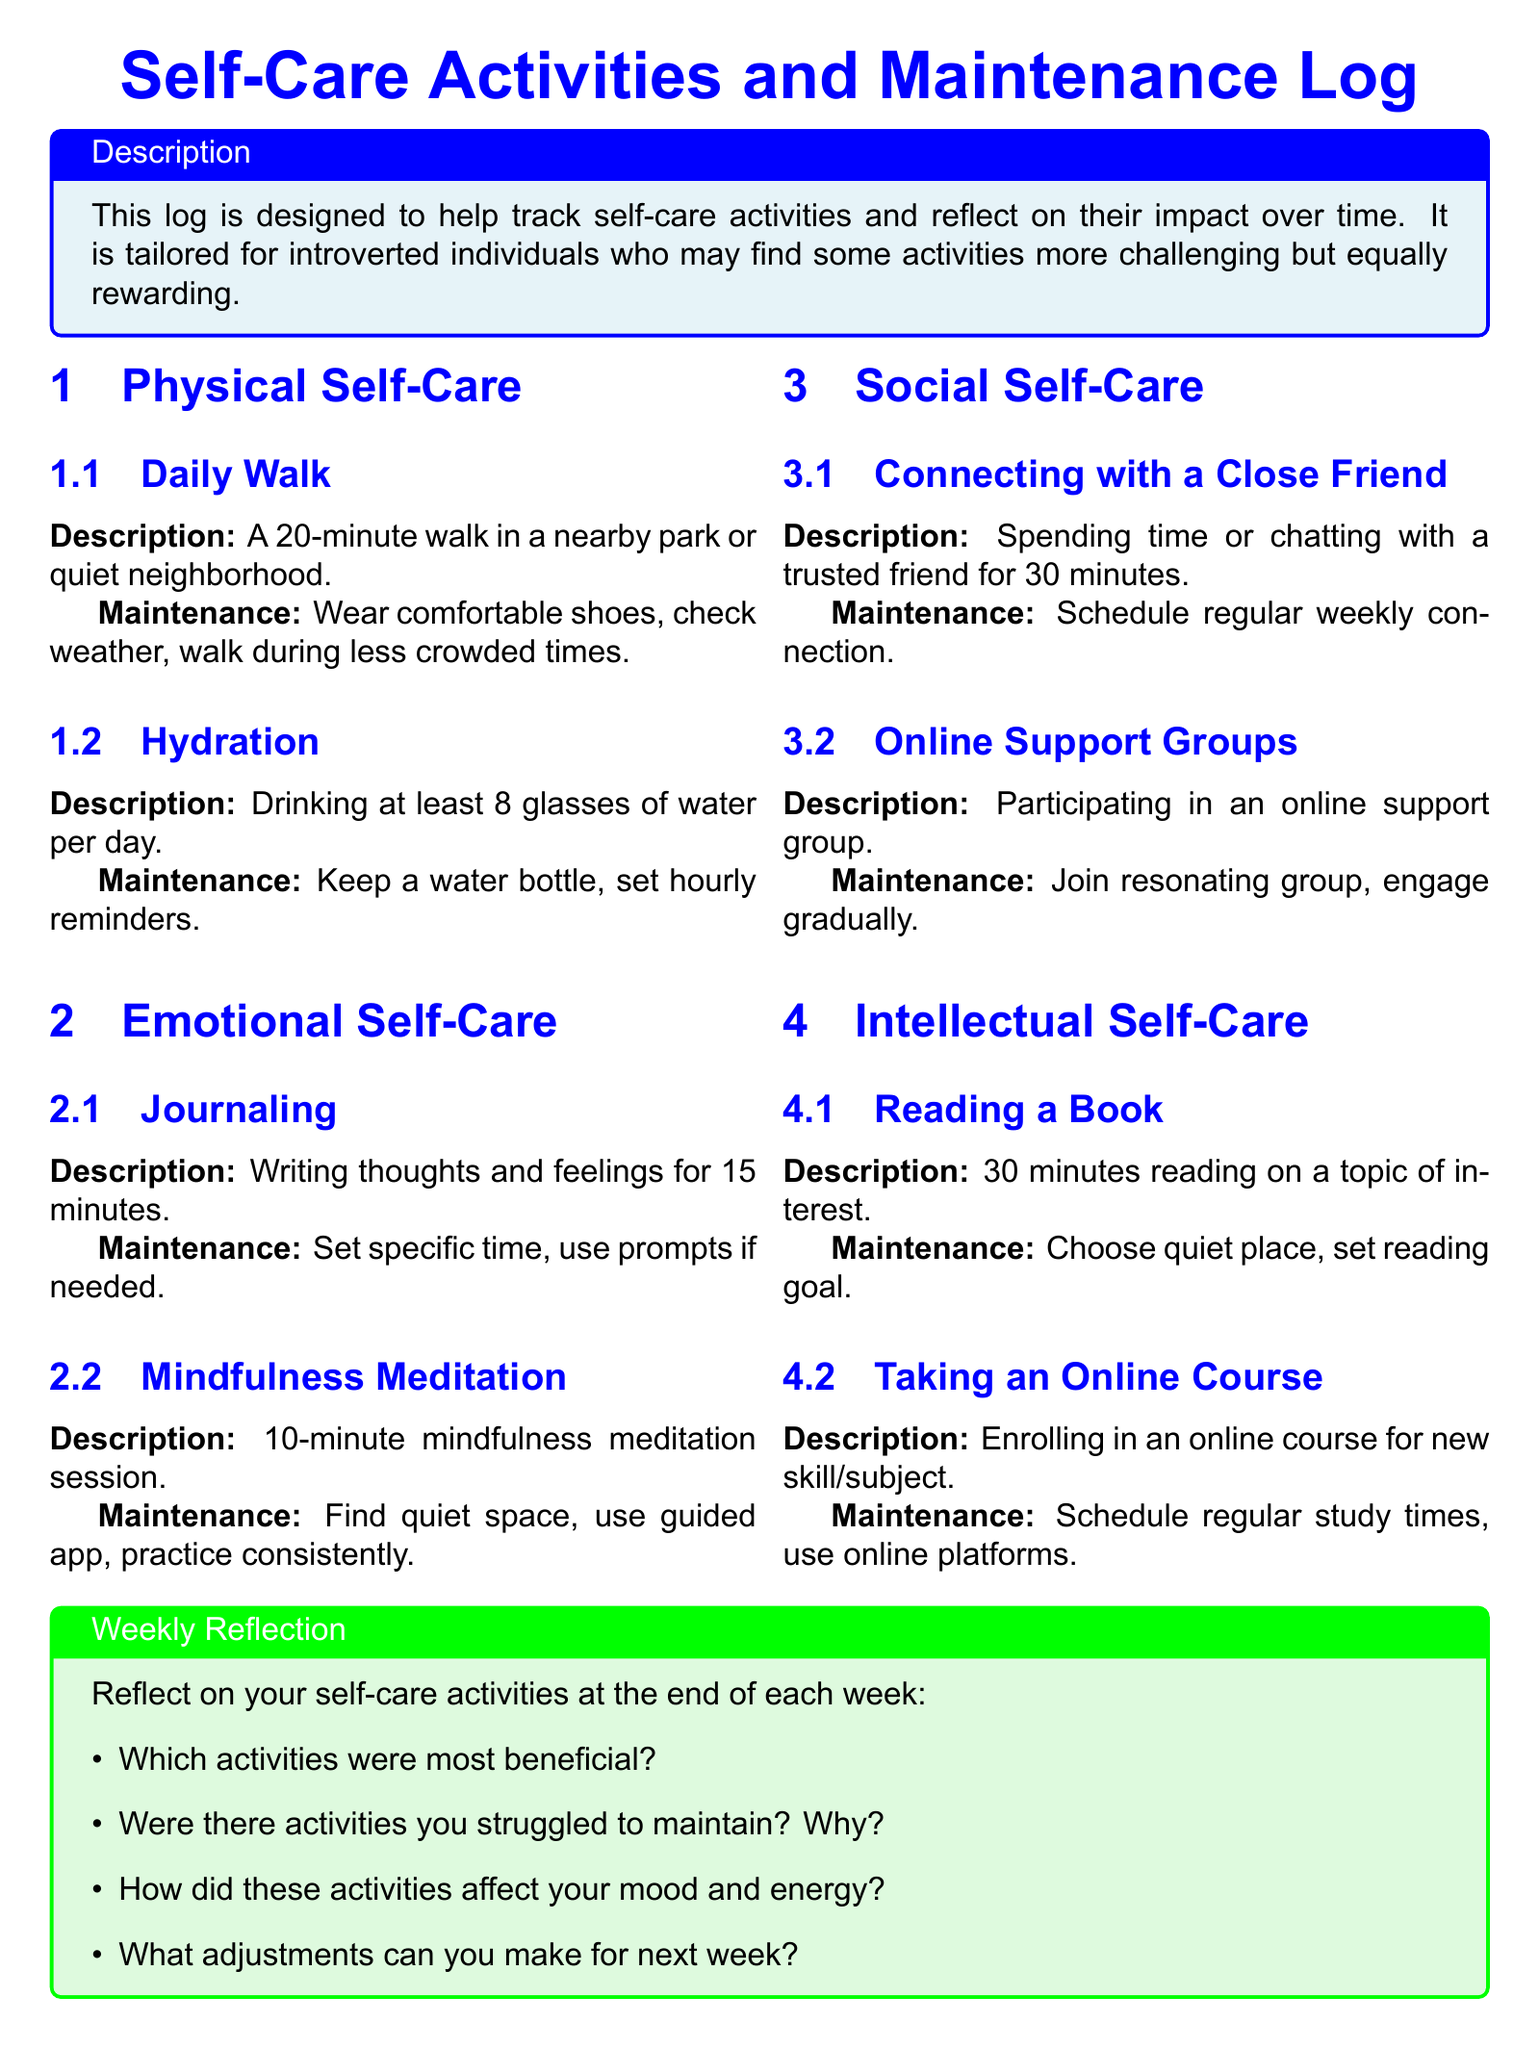what is the title of the document? The title is presented prominently at the start of the document, which is "Self-Care Activities and Maintenance Log."
Answer: Self-Care Activities and Maintenance Log how long should the daily walk be? The daily walk's description mentions a duration of 20 minutes.
Answer: 20 minutes how many glasses of water should be consumed daily? The maintenance section specifies drinking at least 8 glasses of water each day.
Answer: 8 glasses what is one emotional self-care activity listed? The document includes journaling as one of the emotional self-care activities.
Answer: Journaling what adjustment can be made for next week according to the weekly reflection? The reflections suggest making adjustments based on the previous week’s experiences in self-care activities.
Answer: Adjustments how often should you connect with a close friend? The maintenance section mentions scheduling a regular weekly connection with a trusted friend.
Answer: Weekly what is the duration of the mindfulness meditation session? The mindfulness meditation description states a session duration of 10 minutes.
Answer: 10 minutes what is one requirement for taking an online course? The maintenance section advises scheduling regular study times for online courses.
Answer: Schedule regular study times which color is used for the emotional self-care section? The emotional self-care section uses a pastel blue background color.
Answer: Pastel blue 